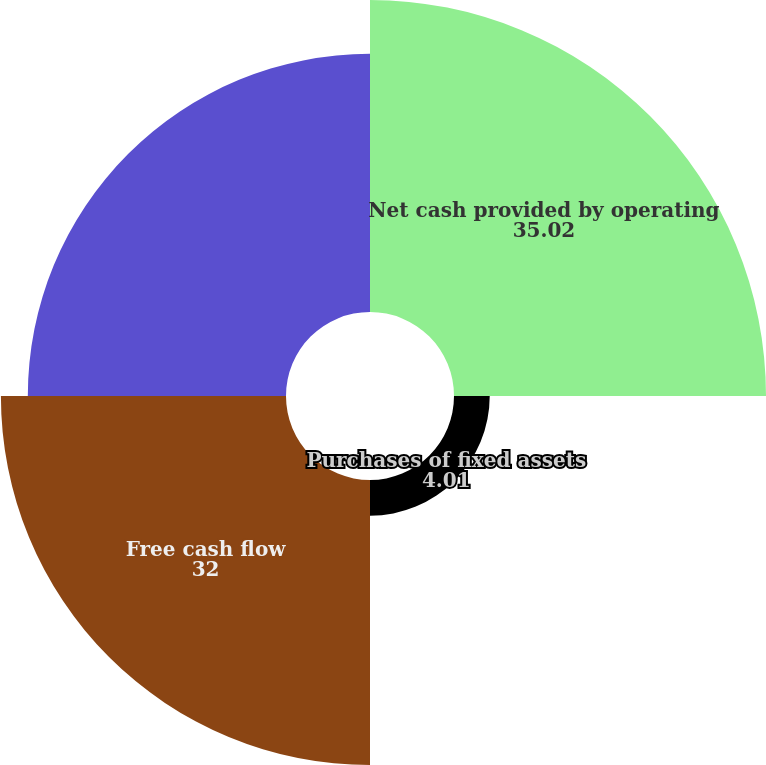Convert chart to OTSL. <chart><loc_0><loc_0><loc_500><loc_500><pie_chart><fcel>Net cash provided by operating<fcel>Purchases of fixed assets<fcel>Free cash flow<fcel>Net cash provided by (used in)<nl><fcel>35.02%<fcel>4.01%<fcel>32.0%<fcel>28.98%<nl></chart> 